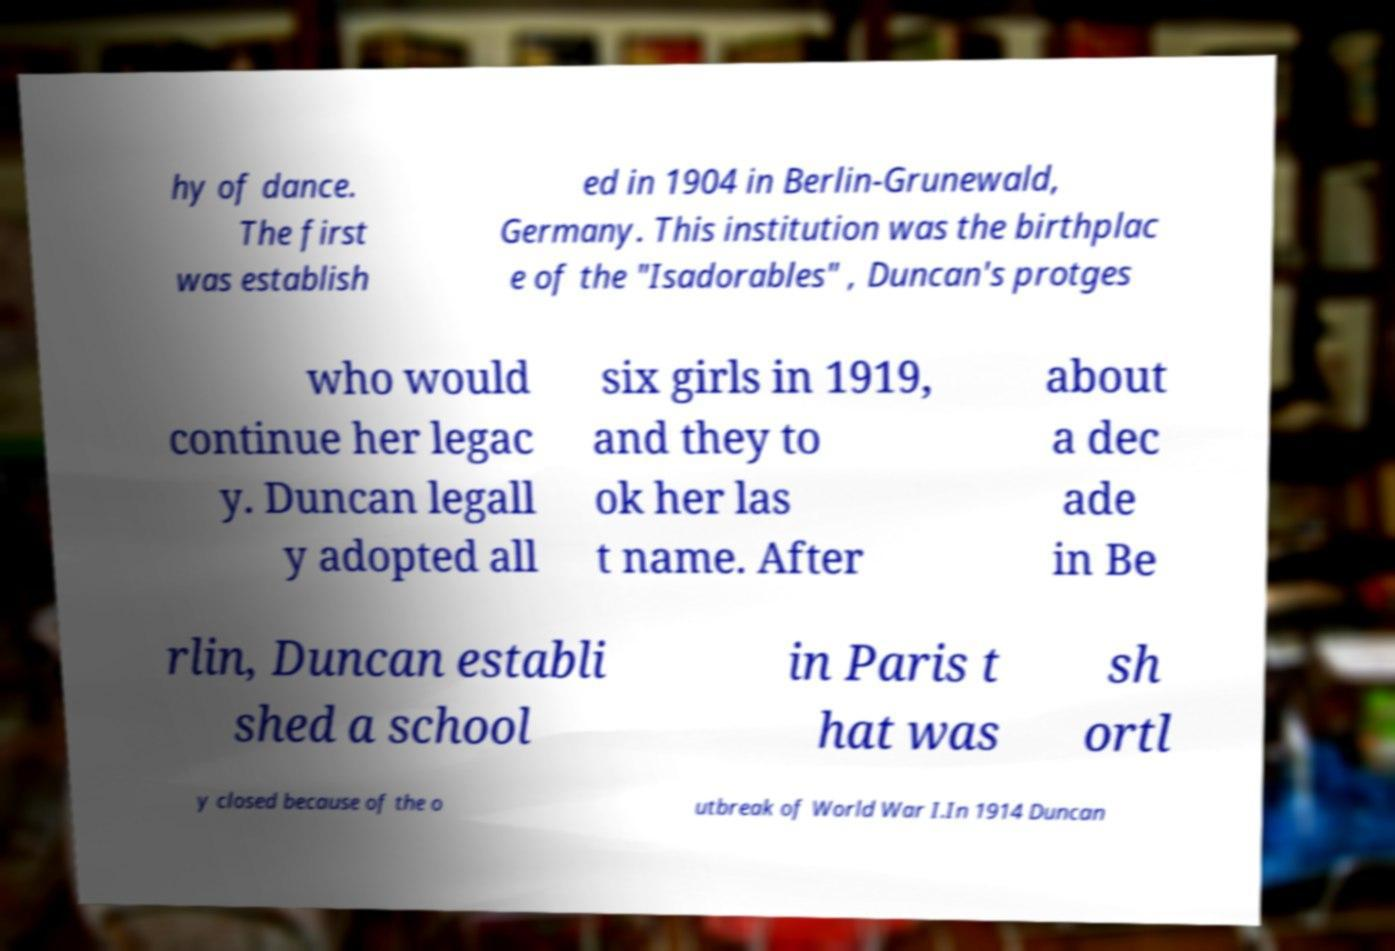Can you read and provide the text displayed in the image?This photo seems to have some interesting text. Can you extract and type it out for me? hy of dance. The first was establish ed in 1904 in Berlin-Grunewald, Germany. This institution was the birthplac e of the "Isadorables" , Duncan's protges who would continue her legac y. Duncan legall y adopted all six girls in 1919, and they to ok her las t name. After about a dec ade in Be rlin, Duncan establi shed a school in Paris t hat was sh ortl y closed because of the o utbreak of World War I.In 1914 Duncan 